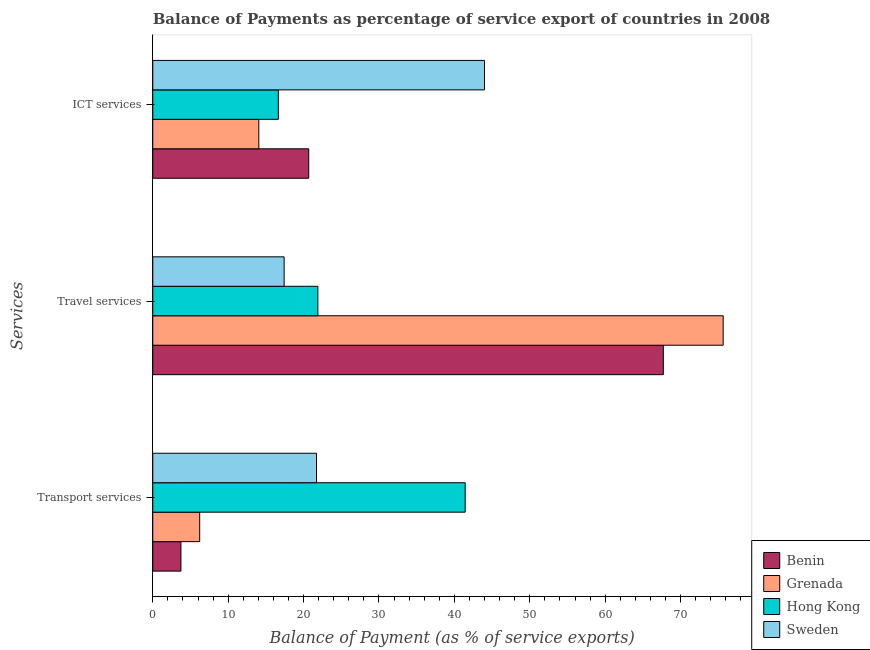How many different coloured bars are there?
Keep it short and to the point. 4. How many bars are there on the 1st tick from the top?
Your answer should be very brief. 4. How many bars are there on the 1st tick from the bottom?
Offer a very short reply. 4. What is the label of the 2nd group of bars from the top?
Ensure brevity in your answer.  Travel services. What is the balance of payment of travel services in Hong Kong?
Make the answer very short. 21.9. Across all countries, what is the maximum balance of payment of ict services?
Provide a short and direct response. 44. Across all countries, what is the minimum balance of payment of ict services?
Offer a very short reply. 14.06. In which country was the balance of payment of travel services maximum?
Ensure brevity in your answer.  Grenada. In which country was the balance of payment of transport services minimum?
Keep it short and to the point. Benin. What is the total balance of payment of travel services in the graph?
Provide a succinct answer. 182.68. What is the difference between the balance of payment of travel services in Grenada and that in Benin?
Make the answer very short. 7.94. What is the difference between the balance of payment of transport services in Grenada and the balance of payment of travel services in Benin?
Keep it short and to the point. -61.49. What is the average balance of payment of travel services per country?
Provide a succinct answer. 45.67. What is the difference between the balance of payment of transport services and balance of payment of ict services in Sweden?
Offer a terse response. -22.28. In how many countries, is the balance of payment of travel services greater than 16 %?
Provide a short and direct response. 4. What is the ratio of the balance of payment of transport services in Hong Kong to that in Benin?
Your answer should be compact. 11.09. Is the balance of payment of travel services in Sweden less than that in Hong Kong?
Offer a very short reply. Yes. What is the difference between the highest and the second highest balance of payment of travel services?
Give a very brief answer. 7.94. What is the difference between the highest and the lowest balance of payment of travel services?
Ensure brevity in your answer.  58.23. In how many countries, is the balance of payment of ict services greater than the average balance of payment of ict services taken over all countries?
Your answer should be very brief. 1. Is the sum of the balance of payment of transport services in Sweden and Grenada greater than the maximum balance of payment of travel services across all countries?
Your answer should be very brief. No. What does the 4th bar from the top in Travel services represents?
Your response must be concise. Benin. What does the 1st bar from the bottom in Transport services represents?
Your response must be concise. Benin. Is it the case that in every country, the sum of the balance of payment of transport services and balance of payment of travel services is greater than the balance of payment of ict services?
Your response must be concise. No. Are all the bars in the graph horizontal?
Your answer should be very brief. Yes. How many countries are there in the graph?
Provide a succinct answer. 4. Are the values on the major ticks of X-axis written in scientific E-notation?
Your answer should be very brief. No. Does the graph contain grids?
Make the answer very short. No. Where does the legend appear in the graph?
Your answer should be very brief. Bottom right. How many legend labels are there?
Make the answer very short. 4. What is the title of the graph?
Offer a terse response. Balance of Payments as percentage of service export of countries in 2008. What is the label or title of the X-axis?
Offer a very short reply. Balance of Payment (as % of service exports). What is the label or title of the Y-axis?
Keep it short and to the point. Services. What is the Balance of Payment (as % of service exports) in Benin in Transport services?
Make the answer very short. 3.73. What is the Balance of Payment (as % of service exports) in Grenada in Transport services?
Give a very brief answer. 6.22. What is the Balance of Payment (as % of service exports) in Hong Kong in Transport services?
Keep it short and to the point. 41.43. What is the Balance of Payment (as % of service exports) in Sweden in Transport services?
Provide a short and direct response. 21.72. What is the Balance of Payment (as % of service exports) in Benin in Travel services?
Your answer should be very brief. 67.71. What is the Balance of Payment (as % of service exports) in Grenada in Travel services?
Provide a short and direct response. 75.65. What is the Balance of Payment (as % of service exports) in Hong Kong in Travel services?
Ensure brevity in your answer.  21.9. What is the Balance of Payment (as % of service exports) in Sweden in Travel services?
Your response must be concise. 17.42. What is the Balance of Payment (as % of service exports) of Benin in ICT services?
Keep it short and to the point. 20.68. What is the Balance of Payment (as % of service exports) in Grenada in ICT services?
Your answer should be very brief. 14.06. What is the Balance of Payment (as % of service exports) of Hong Kong in ICT services?
Provide a succinct answer. 16.65. What is the Balance of Payment (as % of service exports) of Sweden in ICT services?
Give a very brief answer. 44. Across all Services, what is the maximum Balance of Payment (as % of service exports) in Benin?
Provide a short and direct response. 67.71. Across all Services, what is the maximum Balance of Payment (as % of service exports) of Grenada?
Ensure brevity in your answer.  75.65. Across all Services, what is the maximum Balance of Payment (as % of service exports) in Hong Kong?
Give a very brief answer. 41.43. Across all Services, what is the maximum Balance of Payment (as % of service exports) of Sweden?
Make the answer very short. 44. Across all Services, what is the minimum Balance of Payment (as % of service exports) of Benin?
Provide a short and direct response. 3.73. Across all Services, what is the minimum Balance of Payment (as % of service exports) of Grenada?
Your answer should be very brief. 6.22. Across all Services, what is the minimum Balance of Payment (as % of service exports) in Hong Kong?
Offer a very short reply. 16.65. Across all Services, what is the minimum Balance of Payment (as % of service exports) of Sweden?
Provide a succinct answer. 17.42. What is the total Balance of Payment (as % of service exports) of Benin in the graph?
Keep it short and to the point. 92.13. What is the total Balance of Payment (as % of service exports) in Grenada in the graph?
Provide a succinct answer. 95.93. What is the total Balance of Payment (as % of service exports) of Hong Kong in the graph?
Keep it short and to the point. 79.98. What is the total Balance of Payment (as % of service exports) in Sweden in the graph?
Keep it short and to the point. 83.13. What is the difference between the Balance of Payment (as % of service exports) in Benin in Transport services and that in Travel services?
Ensure brevity in your answer.  -63.98. What is the difference between the Balance of Payment (as % of service exports) of Grenada in Transport services and that in Travel services?
Provide a succinct answer. -69.43. What is the difference between the Balance of Payment (as % of service exports) in Hong Kong in Transport services and that in Travel services?
Make the answer very short. 19.54. What is the difference between the Balance of Payment (as % of service exports) in Sweden in Transport services and that in Travel services?
Your response must be concise. 4.3. What is the difference between the Balance of Payment (as % of service exports) of Benin in Transport services and that in ICT services?
Your response must be concise. -16.95. What is the difference between the Balance of Payment (as % of service exports) of Grenada in Transport services and that in ICT services?
Your answer should be compact. -7.84. What is the difference between the Balance of Payment (as % of service exports) in Hong Kong in Transport services and that in ICT services?
Offer a terse response. 24.78. What is the difference between the Balance of Payment (as % of service exports) in Sweden in Transport services and that in ICT services?
Your response must be concise. -22.28. What is the difference between the Balance of Payment (as % of service exports) in Benin in Travel services and that in ICT services?
Ensure brevity in your answer.  47.03. What is the difference between the Balance of Payment (as % of service exports) of Grenada in Travel services and that in ICT services?
Provide a succinct answer. 61.59. What is the difference between the Balance of Payment (as % of service exports) of Hong Kong in Travel services and that in ICT services?
Make the answer very short. 5.24. What is the difference between the Balance of Payment (as % of service exports) of Sweden in Travel services and that in ICT services?
Provide a short and direct response. -26.58. What is the difference between the Balance of Payment (as % of service exports) in Benin in Transport services and the Balance of Payment (as % of service exports) in Grenada in Travel services?
Provide a succinct answer. -71.92. What is the difference between the Balance of Payment (as % of service exports) of Benin in Transport services and the Balance of Payment (as % of service exports) of Hong Kong in Travel services?
Keep it short and to the point. -18.16. What is the difference between the Balance of Payment (as % of service exports) of Benin in Transport services and the Balance of Payment (as % of service exports) of Sweden in Travel services?
Give a very brief answer. -13.69. What is the difference between the Balance of Payment (as % of service exports) in Grenada in Transport services and the Balance of Payment (as % of service exports) in Hong Kong in Travel services?
Offer a terse response. -15.68. What is the difference between the Balance of Payment (as % of service exports) in Grenada in Transport services and the Balance of Payment (as % of service exports) in Sweden in Travel services?
Make the answer very short. -11.2. What is the difference between the Balance of Payment (as % of service exports) in Hong Kong in Transport services and the Balance of Payment (as % of service exports) in Sweden in Travel services?
Offer a very short reply. 24.01. What is the difference between the Balance of Payment (as % of service exports) of Benin in Transport services and the Balance of Payment (as % of service exports) of Grenada in ICT services?
Provide a short and direct response. -10.33. What is the difference between the Balance of Payment (as % of service exports) in Benin in Transport services and the Balance of Payment (as % of service exports) in Hong Kong in ICT services?
Give a very brief answer. -12.92. What is the difference between the Balance of Payment (as % of service exports) in Benin in Transport services and the Balance of Payment (as % of service exports) in Sweden in ICT services?
Keep it short and to the point. -40.26. What is the difference between the Balance of Payment (as % of service exports) of Grenada in Transport services and the Balance of Payment (as % of service exports) of Hong Kong in ICT services?
Ensure brevity in your answer.  -10.43. What is the difference between the Balance of Payment (as % of service exports) in Grenada in Transport services and the Balance of Payment (as % of service exports) in Sweden in ICT services?
Your answer should be compact. -37.77. What is the difference between the Balance of Payment (as % of service exports) in Hong Kong in Transport services and the Balance of Payment (as % of service exports) in Sweden in ICT services?
Give a very brief answer. -2.56. What is the difference between the Balance of Payment (as % of service exports) of Benin in Travel services and the Balance of Payment (as % of service exports) of Grenada in ICT services?
Your answer should be very brief. 53.65. What is the difference between the Balance of Payment (as % of service exports) in Benin in Travel services and the Balance of Payment (as % of service exports) in Hong Kong in ICT services?
Provide a succinct answer. 51.06. What is the difference between the Balance of Payment (as % of service exports) of Benin in Travel services and the Balance of Payment (as % of service exports) of Sweden in ICT services?
Keep it short and to the point. 23.72. What is the difference between the Balance of Payment (as % of service exports) in Grenada in Travel services and the Balance of Payment (as % of service exports) in Hong Kong in ICT services?
Your answer should be compact. 59. What is the difference between the Balance of Payment (as % of service exports) of Grenada in Travel services and the Balance of Payment (as % of service exports) of Sweden in ICT services?
Offer a very short reply. 31.65. What is the difference between the Balance of Payment (as % of service exports) in Hong Kong in Travel services and the Balance of Payment (as % of service exports) in Sweden in ICT services?
Offer a terse response. -22.1. What is the average Balance of Payment (as % of service exports) of Benin per Services?
Offer a very short reply. 30.71. What is the average Balance of Payment (as % of service exports) of Grenada per Services?
Offer a terse response. 31.98. What is the average Balance of Payment (as % of service exports) in Hong Kong per Services?
Keep it short and to the point. 26.66. What is the average Balance of Payment (as % of service exports) in Sweden per Services?
Ensure brevity in your answer.  27.71. What is the difference between the Balance of Payment (as % of service exports) of Benin and Balance of Payment (as % of service exports) of Grenada in Transport services?
Give a very brief answer. -2.49. What is the difference between the Balance of Payment (as % of service exports) in Benin and Balance of Payment (as % of service exports) in Hong Kong in Transport services?
Make the answer very short. -37.7. What is the difference between the Balance of Payment (as % of service exports) of Benin and Balance of Payment (as % of service exports) of Sweden in Transport services?
Give a very brief answer. -17.98. What is the difference between the Balance of Payment (as % of service exports) of Grenada and Balance of Payment (as % of service exports) of Hong Kong in Transport services?
Your answer should be very brief. -35.21. What is the difference between the Balance of Payment (as % of service exports) in Grenada and Balance of Payment (as % of service exports) in Sweden in Transport services?
Your answer should be compact. -15.5. What is the difference between the Balance of Payment (as % of service exports) in Hong Kong and Balance of Payment (as % of service exports) in Sweden in Transport services?
Provide a succinct answer. 19.72. What is the difference between the Balance of Payment (as % of service exports) of Benin and Balance of Payment (as % of service exports) of Grenada in Travel services?
Your answer should be compact. -7.94. What is the difference between the Balance of Payment (as % of service exports) of Benin and Balance of Payment (as % of service exports) of Hong Kong in Travel services?
Give a very brief answer. 45.81. What is the difference between the Balance of Payment (as % of service exports) in Benin and Balance of Payment (as % of service exports) in Sweden in Travel services?
Ensure brevity in your answer.  50.29. What is the difference between the Balance of Payment (as % of service exports) in Grenada and Balance of Payment (as % of service exports) in Hong Kong in Travel services?
Your response must be concise. 53.75. What is the difference between the Balance of Payment (as % of service exports) in Grenada and Balance of Payment (as % of service exports) in Sweden in Travel services?
Your response must be concise. 58.23. What is the difference between the Balance of Payment (as % of service exports) in Hong Kong and Balance of Payment (as % of service exports) in Sweden in Travel services?
Keep it short and to the point. 4.48. What is the difference between the Balance of Payment (as % of service exports) in Benin and Balance of Payment (as % of service exports) in Grenada in ICT services?
Your answer should be very brief. 6.62. What is the difference between the Balance of Payment (as % of service exports) of Benin and Balance of Payment (as % of service exports) of Hong Kong in ICT services?
Offer a very short reply. 4.03. What is the difference between the Balance of Payment (as % of service exports) of Benin and Balance of Payment (as % of service exports) of Sweden in ICT services?
Make the answer very short. -23.31. What is the difference between the Balance of Payment (as % of service exports) of Grenada and Balance of Payment (as % of service exports) of Hong Kong in ICT services?
Keep it short and to the point. -2.59. What is the difference between the Balance of Payment (as % of service exports) in Grenada and Balance of Payment (as % of service exports) in Sweden in ICT services?
Your answer should be very brief. -29.93. What is the difference between the Balance of Payment (as % of service exports) in Hong Kong and Balance of Payment (as % of service exports) in Sweden in ICT services?
Your answer should be compact. -27.34. What is the ratio of the Balance of Payment (as % of service exports) in Benin in Transport services to that in Travel services?
Ensure brevity in your answer.  0.06. What is the ratio of the Balance of Payment (as % of service exports) of Grenada in Transport services to that in Travel services?
Offer a terse response. 0.08. What is the ratio of the Balance of Payment (as % of service exports) of Hong Kong in Transport services to that in Travel services?
Keep it short and to the point. 1.89. What is the ratio of the Balance of Payment (as % of service exports) of Sweden in Transport services to that in Travel services?
Provide a short and direct response. 1.25. What is the ratio of the Balance of Payment (as % of service exports) in Benin in Transport services to that in ICT services?
Your response must be concise. 0.18. What is the ratio of the Balance of Payment (as % of service exports) in Grenada in Transport services to that in ICT services?
Your answer should be compact. 0.44. What is the ratio of the Balance of Payment (as % of service exports) in Hong Kong in Transport services to that in ICT services?
Offer a terse response. 2.49. What is the ratio of the Balance of Payment (as % of service exports) in Sweden in Transport services to that in ICT services?
Make the answer very short. 0.49. What is the ratio of the Balance of Payment (as % of service exports) in Benin in Travel services to that in ICT services?
Provide a short and direct response. 3.27. What is the ratio of the Balance of Payment (as % of service exports) in Grenada in Travel services to that in ICT services?
Provide a succinct answer. 5.38. What is the ratio of the Balance of Payment (as % of service exports) in Hong Kong in Travel services to that in ICT services?
Your answer should be very brief. 1.31. What is the ratio of the Balance of Payment (as % of service exports) of Sweden in Travel services to that in ICT services?
Ensure brevity in your answer.  0.4. What is the difference between the highest and the second highest Balance of Payment (as % of service exports) of Benin?
Provide a succinct answer. 47.03. What is the difference between the highest and the second highest Balance of Payment (as % of service exports) in Grenada?
Give a very brief answer. 61.59. What is the difference between the highest and the second highest Balance of Payment (as % of service exports) in Hong Kong?
Your answer should be compact. 19.54. What is the difference between the highest and the second highest Balance of Payment (as % of service exports) in Sweden?
Offer a terse response. 22.28. What is the difference between the highest and the lowest Balance of Payment (as % of service exports) in Benin?
Offer a terse response. 63.98. What is the difference between the highest and the lowest Balance of Payment (as % of service exports) of Grenada?
Make the answer very short. 69.43. What is the difference between the highest and the lowest Balance of Payment (as % of service exports) in Hong Kong?
Offer a very short reply. 24.78. What is the difference between the highest and the lowest Balance of Payment (as % of service exports) in Sweden?
Provide a short and direct response. 26.58. 